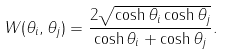Convert formula to latex. <formula><loc_0><loc_0><loc_500><loc_500>W ( \theta _ { i } , \theta _ { j } ) = \frac { 2 \sqrt { \cosh \theta _ { i } \cosh \theta _ { j } } } { \cosh \theta _ { i } + \cosh \theta _ { j } } .</formula> 